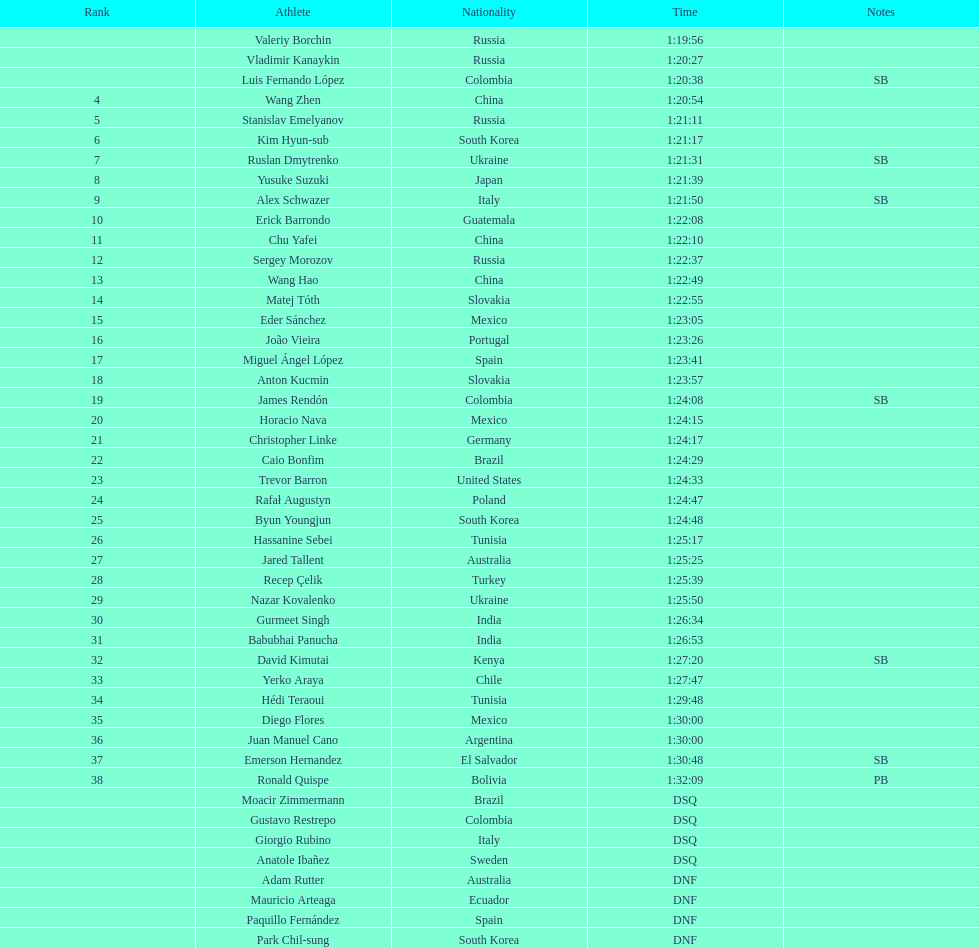Which athlete is the only american to be ranked in the 20km? Trevor Barron. Could you parse the entire table as a dict? {'header': ['Rank', 'Athlete', 'Nationality', 'Time', 'Notes'], 'rows': [['', 'Valeriy Borchin', 'Russia', '1:19:56', ''], ['', 'Vladimir Kanaykin', 'Russia', '1:20:27', ''], ['', 'Luis Fernando López', 'Colombia', '1:20:38', 'SB'], ['4', 'Wang Zhen', 'China', '1:20:54', ''], ['5', 'Stanislav Emelyanov', 'Russia', '1:21:11', ''], ['6', 'Kim Hyun-sub', 'South Korea', '1:21:17', ''], ['7', 'Ruslan Dmytrenko', 'Ukraine', '1:21:31', 'SB'], ['8', 'Yusuke Suzuki', 'Japan', '1:21:39', ''], ['9', 'Alex Schwazer', 'Italy', '1:21:50', 'SB'], ['10', 'Erick Barrondo', 'Guatemala', '1:22:08', ''], ['11', 'Chu Yafei', 'China', '1:22:10', ''], ['12', 'Sergey Morozov', 'Russia', '1:22:37', ''], ['13', 'Wang Hao', 'China', '1:22:49', ''], ['14', 'Matej Tóth', 'Slovakia', '1:22:55', ''], ['15', 'Eder Sánchez', 'Mexico', '1:23:05', ''], ['16', 'João Vieira', 'Portugal', '1:23:26', ''], ['17', 'Miguel Ángel López', 'Spain', '1:23:41', ''], ['18', 'Anton Kucmin', 'Slovakia', '1:23:57', ''], ['19', 'James Rendón', 'Colombia', '1:24:08', 'SB'], ['20', 'Horacio Nava', 'Mexico', '1:24:15', ''], ['21', 'Christopher Linke', 'Germany', '1:24:17', ''], ['22', 'Caio Bonfim', 'Brazil', '1:24:29', ''], ['23', 'Trevor Barron', 'United States', '1:24:33', ''], ['24', 'Rafał Augustyn', 'Poland', '1:24:47', ''], ['25', 'Byun Youngjun', 'South Korea', '1:24:48', ''], ['26', 'Hassanine Sebei', 'Tunisia', '1:25:17', ''], ['27', 'Jared Tallent', 'Australia', '1:25:25', ''], ['28', 'Recep Çelik', 'Turkey', '1:25:39', ''], ['29', 'Nazar Kovalenko', 'Ukraine', '1:25:50', ''], ['30', 'Gurmeet Singh', 'India', '1:26:34', ''], ['31', 'Babubhai Panucha', 'India', '1:26:53', ''], ['32', 'David Kimutai', 'Kenya', '1:27:20', 'SB'], ['33', 'Yerko Araya', 'Chile', '1:27:47', ''], ['34', 'Hédi Teraoui', 'Tunisia', '1:29:48', ''], ['35', 'Diego Flores', 'Mexico', '1:30:00', ''], ['36', 'Juan Manuel Cano', 'Argentina', '1:30:00', ''], ['37', 'Emerson Hernandez', 'El Salvador', '1:30:48', 'SB'], ['38', 'Ronald Quispe', 'Bolivia', '1:32:09', 'PB'], ['', 'Moacir Zimmermann', 'Brazil', 'DSQ', ''], ['', 'Gustavo Restrepo', 'Colombia', 'DSQ', ''], ['', 'Giorgio Rubino', 'Italy', 'DSQ', ''], ['', 'Anatole Ibañez', 'Sweden', 'DSQ', ''], ['', 'Adam Rutter', 'Australia', 'DNF', ''], ['', 'Mauricio Arteaga', 'Ecuador', 'DNF', ''], ['', 'Paquillo Fernández', 'Spain', 'DNF', ''], ['', 'Park Chil-sung', 'South Korea', 'DNF', '']]} 